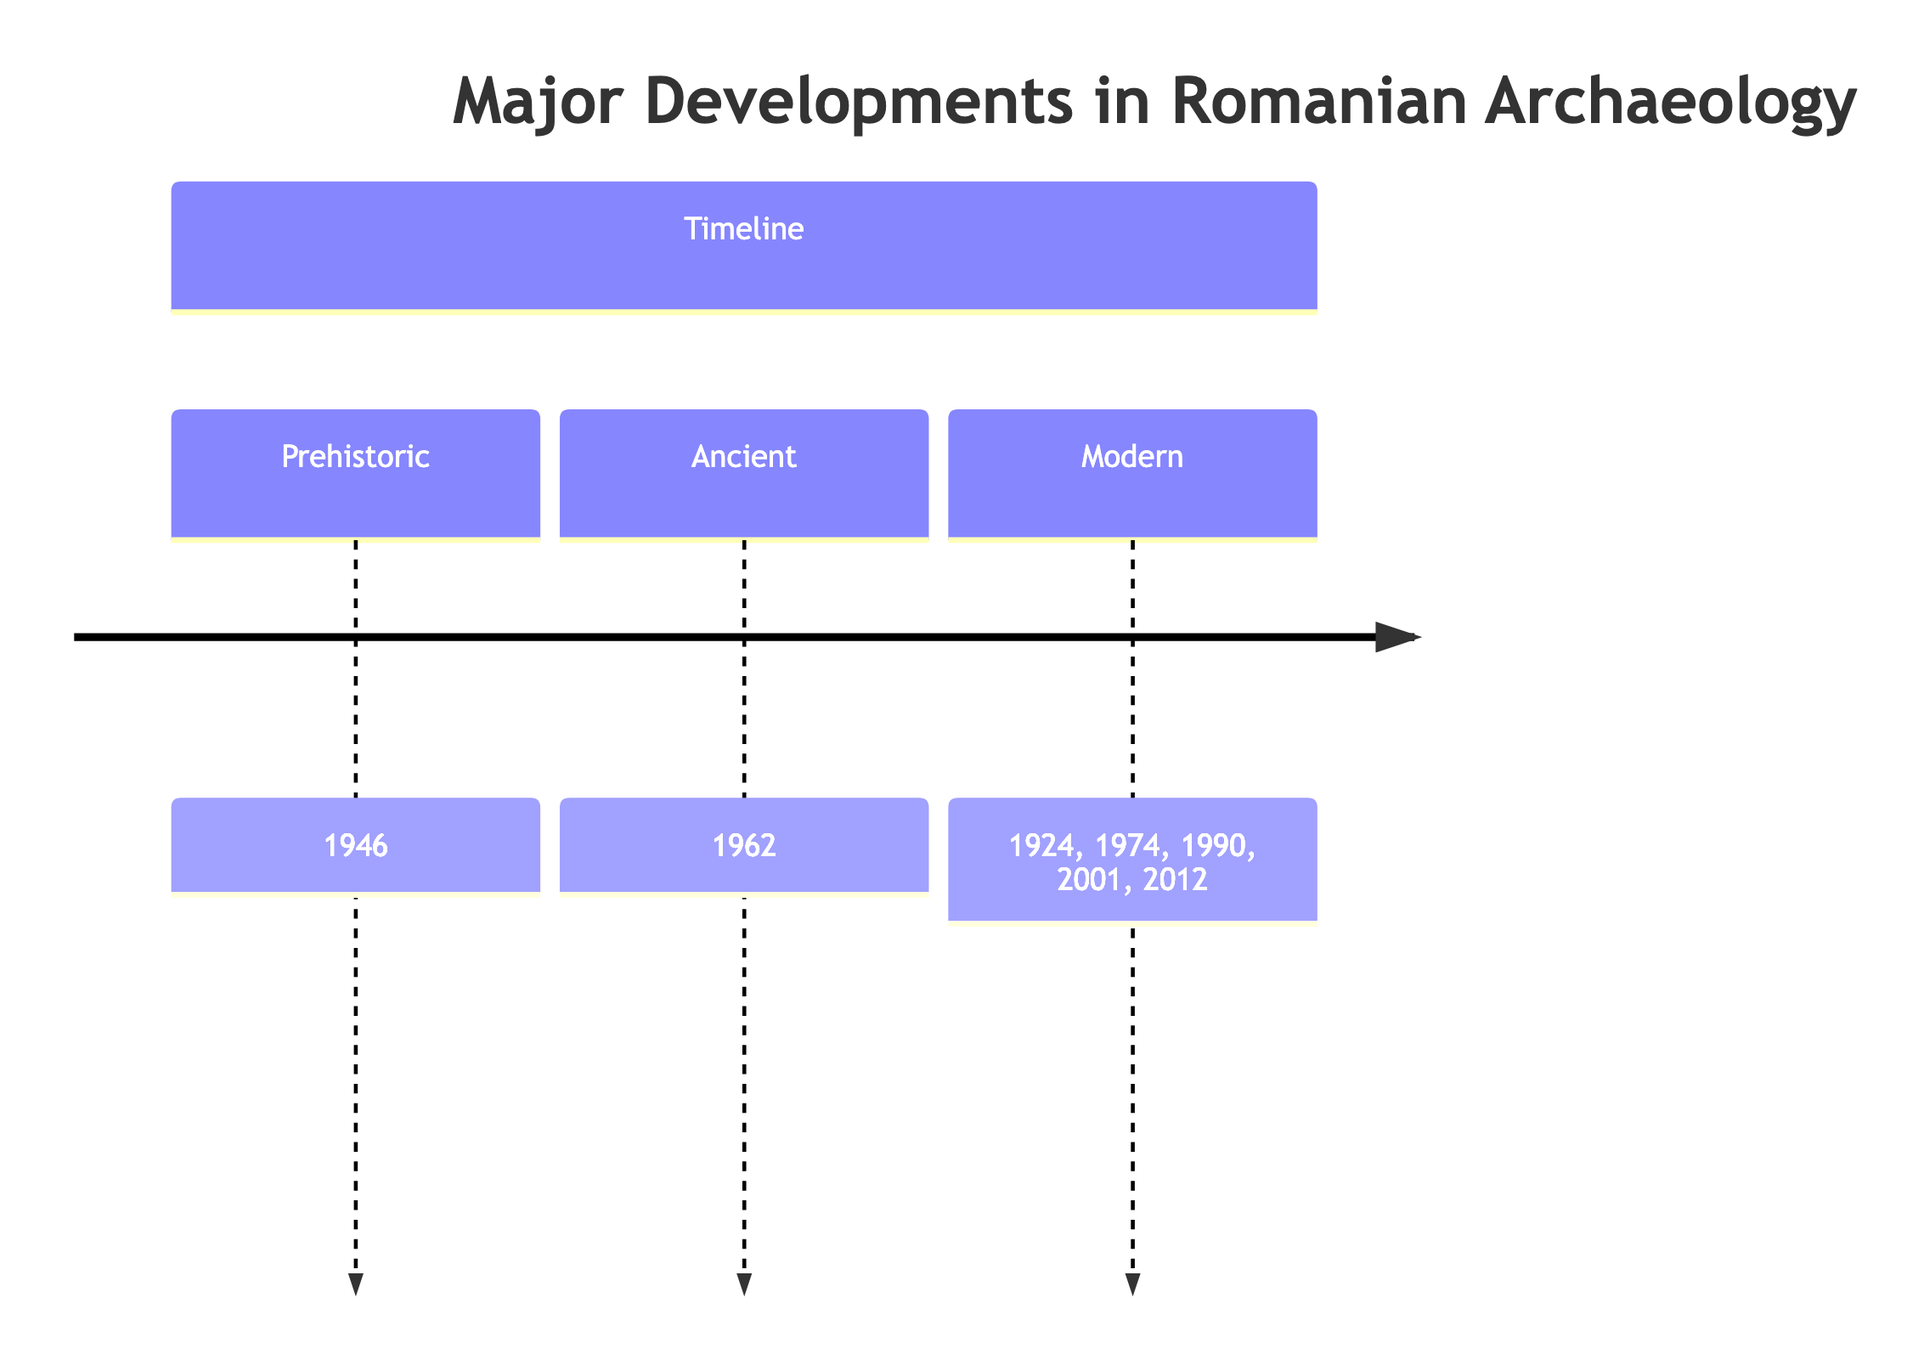What year was the National Museum of Romanian History established? The timeline indicates that the establishment of the National Museum of Romanian History took place in 1924.
Answer: 1924 Which event is associated with the year 2001? According to the timeline, the event associated with the year 2001 is the UNESCO World Heritage Status for Dacian Fortresses.
Answer: UNESCO World Heritage Status for Dacian Fortresses How many major developments in Romanian archaeology are listed on the timeline? By counting the events presented on the timeline, there are a total of seven major developments listed.
Answer: 7 What significant archaeological discovery occurred in 1946? The timeline specifies that the significant discovery in 1946 was of the Tărtăria Tablets.
Answer: Discovery of Tărtăria Tablets What was the focus of the Cernavodă Culture Study in 1974? The timeline describes that the Cernavodă Culture Study focused on extensive research into the neolithic Cernavodă culture, highlighting significant aspects such as pottery and burial practices.
Answer: Extensive research into neolithic Cernavodă culture Which event marks the transition between ancient and modern archaeology in Romania? Reviewing the timeline, the event marking this transition is the Sarmizegetusa Regia Excavations in 1962, which links to major insights into Dacian culture prior to modern advancements.
Answer: Sarmizegetusa Regia Excavations What is the earliest event listed on the timeline? The timeline indicates that the earliest event listed is the establishment of the National Museum of Romanian History in 1924.
Answer: Establishment of the National Museum of Romanian History What reform was instituted in 2012? According to the timeline, the reform instituted in 2012 was the Romanian Archaeological Institute Reforms aimed at enhancing research methodologies and field techniques.
Answer: Romanian Archaeological Institute Reforms Which major archaeological event occurred in Albania County? The timeline details that the discovery of the Tărtăria Tablets occurred in Alba County in 1946.
Answer: Discovery of Tărtăria Tablets 